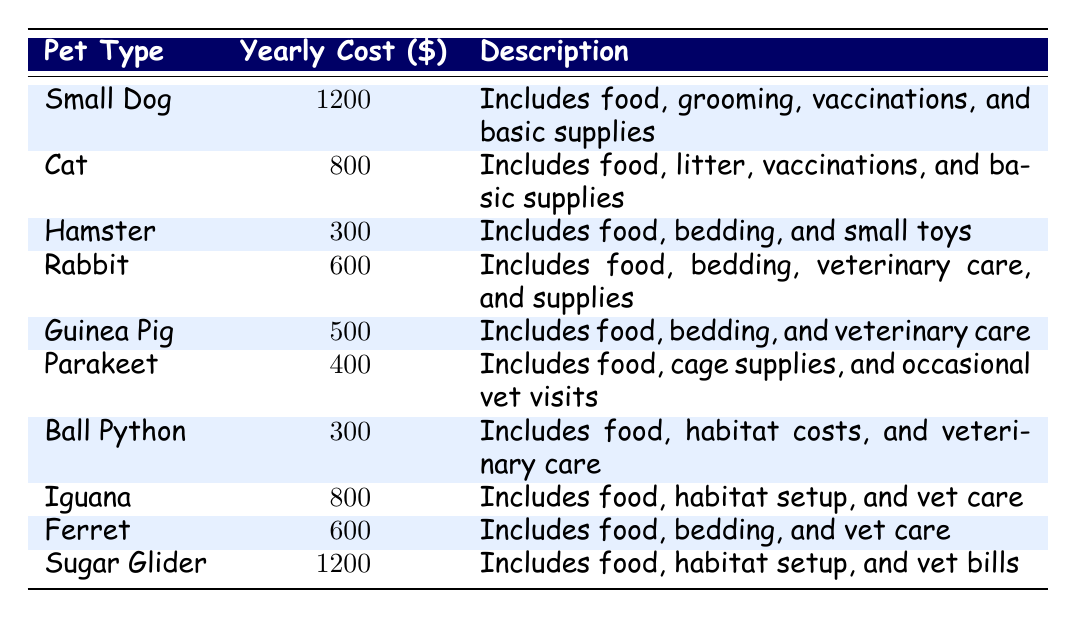What is the highest yearly cost among the small pets? The table lists several pets and their respective yearly costs. By scanning through, we find that both the Small Dog and Sugar Glider have the highest cost at 1200.
Answer: 1200 Which pet has the lowest yearly cost? Looking at the yearly costs listed in the table, the Hamster has the lowest cost at 300.
Answer: 300 What is the total yearly cost for all the small pets combined? To find the total, we sum up each pet's yearly cost: 1200 + 800 + 300 + 600 + 500 + 400 + 300 + 800 + 600 + 1200 = 5100.
Answer: 5100 Is the yearly cost of an Iguana greater than that of a Rabbit? The table shows that the yearly cost for an Iguana is 800, while for a Rabbit, it is 600. Therefore, yes, the cost of an Iguana is greater.
Answer: Yes What is the average yearly cost of all the small pets listed? To find the average, we take the total cost (5100, calculated earlier) and divide it by the number of pets (10). Thus, 5100 ÷ 10 = 510.
Answer: 510 How much more does a Small Dog cost compared to a Parakeet? The Small Dog costs 1200, and the Parakeet costs 400. Subtracting 400 from 1200 gives us 800.
Answer: 800 Are there any pets with a yearly cost of over 600? Reviewing the table, the Small Dog (1200), Cat (800), Iguana (800), and Sugar Glider (1200) all have costs over 600.
Answer: Yes Which type of pet is comparable in cost to the Ferret? The Ferret costs 600, and the Rabbit also costs 600. Therefore, the Rabbit is comparable.
Answer: Rabbit What percentage of the total yearly cost does the Ball Python represent? The Ball Python costs 300, and the total yearly cost is 5100. To find the percentage, (300 ÷ 5100) × 100 gives approximately 5.88%.
Answer: About 5.88% What pet types have yearly costs less than or equal to 500? From the table, the Hamster (300), Guinea Pig (500), and Parakeet (400) all fit this criteria.
Answer: Hamster, Guinea Pig, Parakeet 